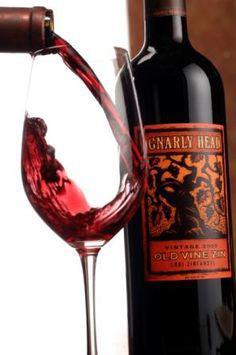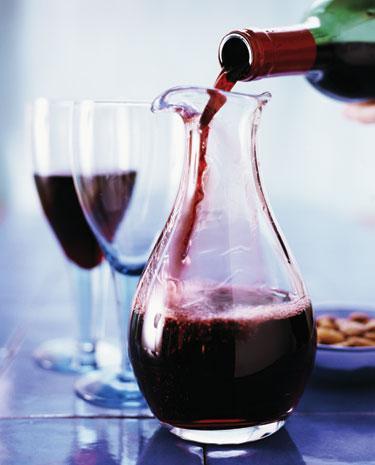The first image is the image on the left, the second image is the image on the right. Examine the images to the left and right. Is the description "An image shows only several partly filled wine glasses." accurate? Answer yes or no. No. The first image is the image on the left, the second image is the image on the right. Analyze the images presented: Is the assertion "there is a bottle of wine in the iamge on the left" valid? Answer yes or no. Yes. 